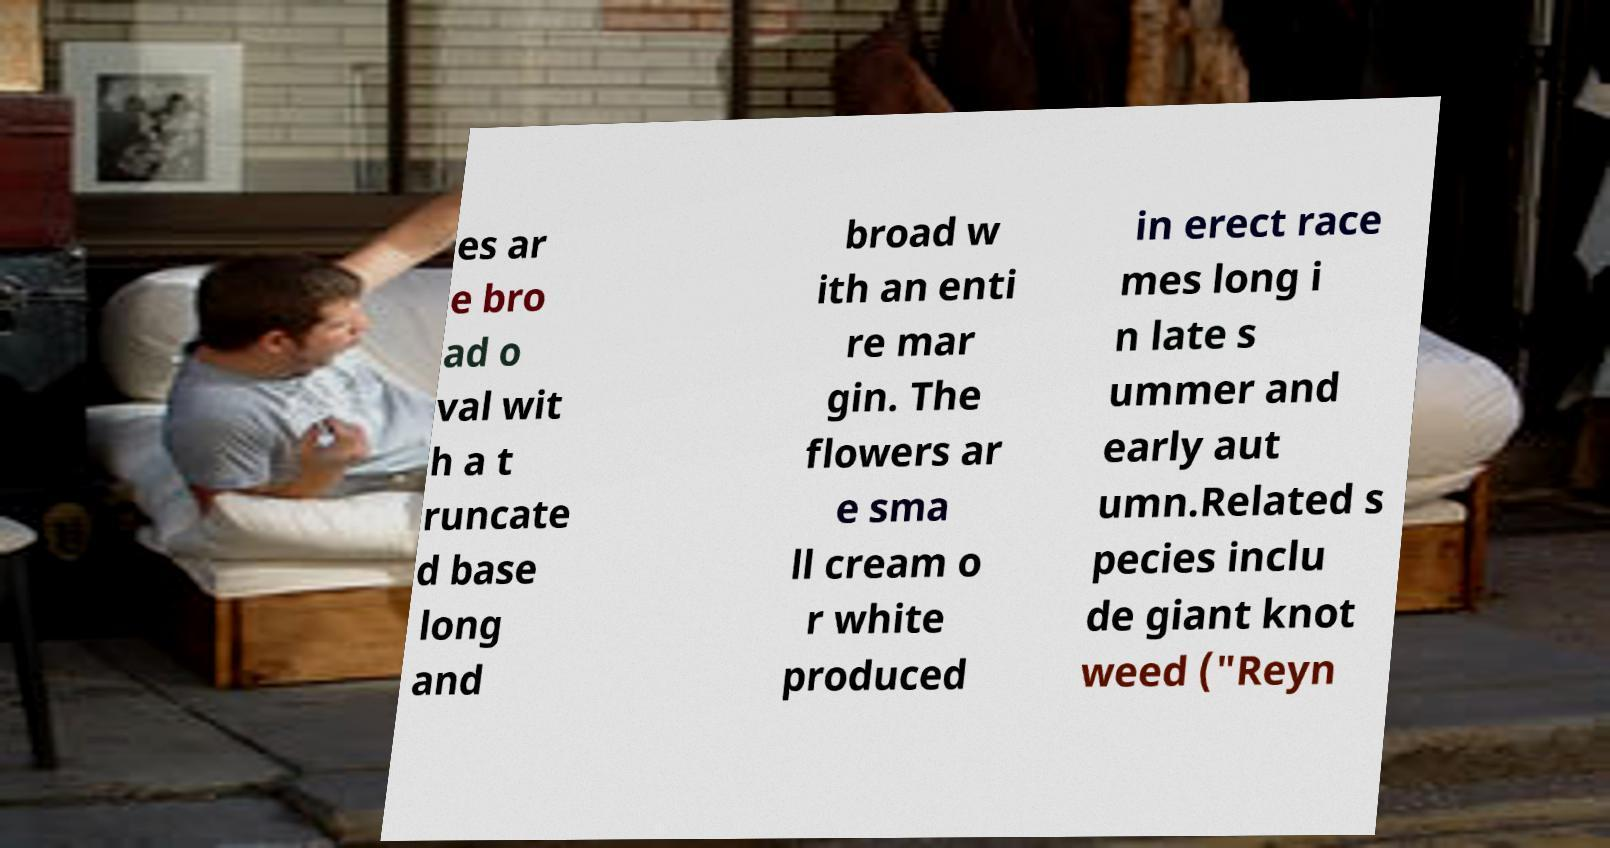Please identify and transcribe the text found in this image. es ar e bro ad o val wit h a t runcate d base long and broad w ith an enti re mar gin. The flowers ar e sma ll cream o r white produced in erect race mes long i n late s ummer and early aut umn.Related s pecies inclu de giant knot weed ("Reyn 